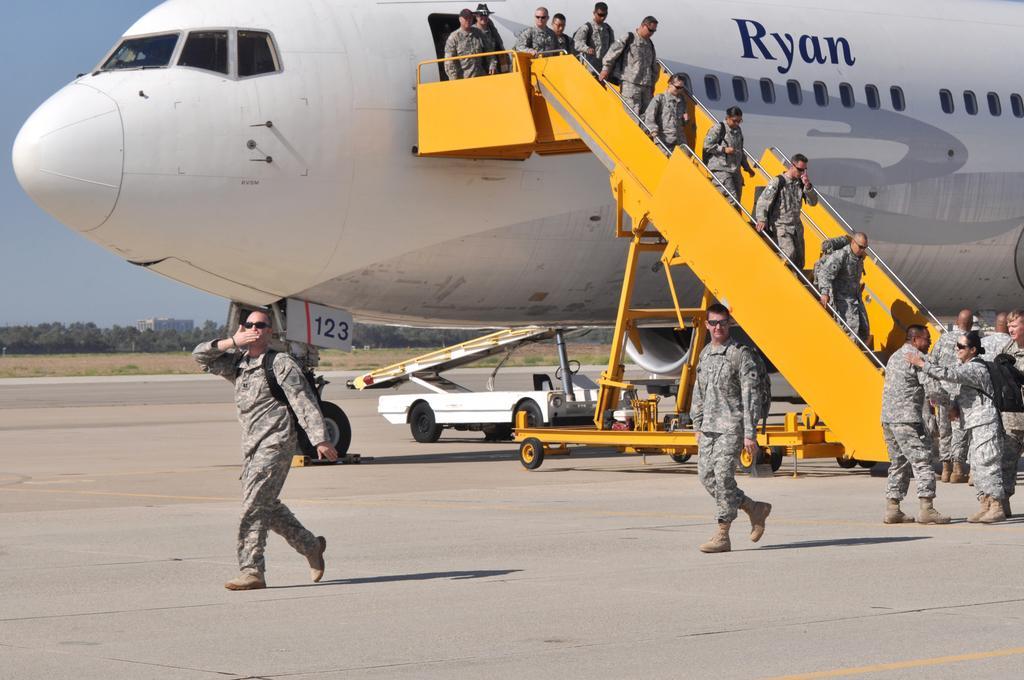In one or two sentences, can you explain what this image depicts? In this picture there are people and we can see an airplane and vehicle on the road. In the background of the image we can see ground, trees, building and sky. 